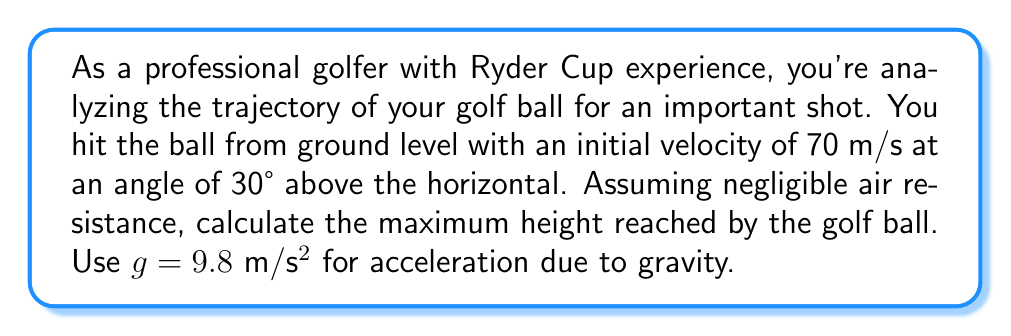Give your solution to this math problem. Let's approach this step-by-step using the principles of projectile motion and parabolic curves:

1) The trajectory of a golf ball can be modeled as a parabola, described by the equation:

   $$y = x \tan \theta - \frac{gx^2}{2v_0^2 \cos^2 \theta}$$

   where $y$ is the height, $x$ is the horizontal distance, $\theta$ is the launch angle, $v_0$ is the initial velocity, and $g$ is the acceleration due to gravity.

2) To find the maximum height, we need to use the vertical component of the motion. The vertical velocity $v_y$ is given by:

   $$v_y = v_0 \sin \theta - gt$$

3) The maximum height occurs when the vertical velocity becomes zero. So, we can find the time to reach maximum height:

   $$0 = v_0 \sin \theta - gt_{\text{max}}$$
   $$t_{\text{max}} = \frac{v_0 \sin \theta}{g}$$

4) Substituting the given values:

   $$t_{\text{max}} = \frac{70 \sin 30°}{9.8} = \frac{70 \cdot 0.5}{9.8} \approx 3.57 \text{ seconds}$$

5) Now, we can use the equation for vertical displacement to find the maximum height:

   $$y_{\text{max}} = v_0 \sin \theta \cdot t_{\text{max}} - \frac{1}{2}gt_{\text{max}}^2$$

6) Substituting the values:

   $$y_{\text{max}} = 70 \sin 30° \cdot 3.57 - \frac{1}{2} \cdot 9.8 \cdot 3.57^2$$
   $$y_{\text{max}} = 70 \cdot 0.5 \cdot 3.57 - 4.9 \cdot 12.74$$
   $$y_{\text{max}} = 124.95 - 62.43 \approx 62.52 \text{ meters}$$

Therefore, the maximum height reached by the golf ball is approximately 62.52 meters.
Answer: The maximum height reached by the golf ball is approximately 62.52 meters. 